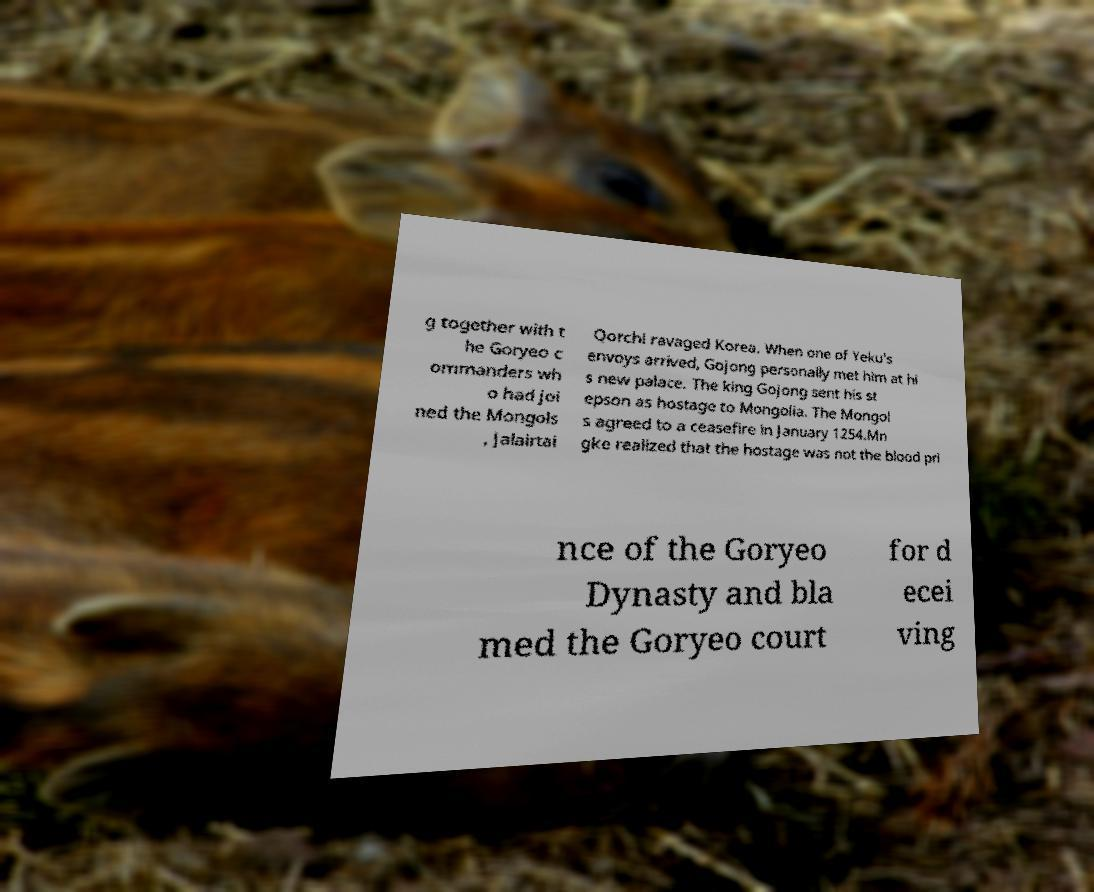Could you assist in decoding the text presented in this image and type it out clearly? g together with t he Goryeo c ommanders wh o had joi ned the Mongols , Jalairtai Qorchi ravaged Korea. When one of Yeku's envoys arrived, Gojong personally met him at hi s new palace. The king Gojong sent his st epson as hostage to Mongolia. The Mongol s agreed to a ceasefire in January 1254.Mn gke realized that the hostage was not the blood pri nce of the Goryeo Dynasty and bla med the Goryeo court for d ecei ving 